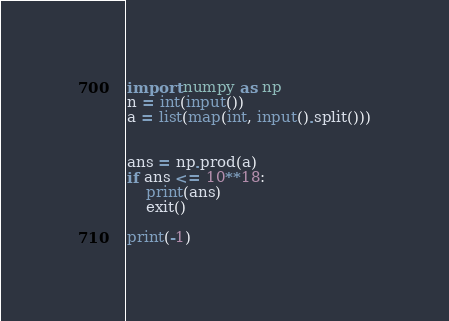Convert code to text. <code><loc_0><loc_0><loc_500><loc_500><_Python_>import numpy as np
n = int(input())
a = list(map(int, input().split()))


ans = np.prod(a)
if ans <= 10**18:
    print(ans)
    exit()

print(-1)
</code> 